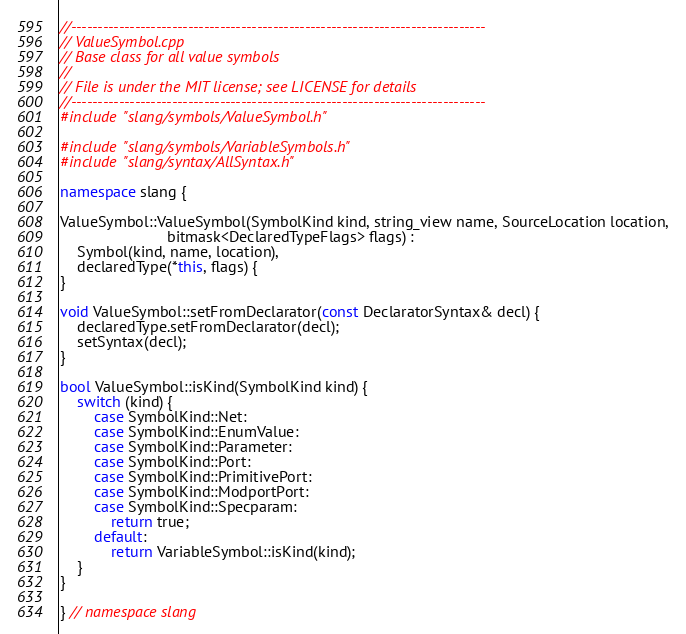<code> <loc_0><loc_0><loc_500><loc_500><_C++_>//------------------------------------------------------------------------------
// ValueSymbol.cpp
// Base class for all value symbols
//
// File is under the MIT license; see LICENSE for details
//------------------------------------------------------------------------------
#include "slang/symbols/ValueSymbol.h"

#include "slang/symbols/VariableSymbols.h"
#include "slang/syntax/AllSyntax.h"

namespace slang {

ValueSymbol::ValueSymbol(SymbolKind kind, string_view name, SourceLocation location,
                         bitmask<DeclaredTypeFlags> flags) :
    Symbol(kind, name, location),
    declaredType(*this, flags) {
}

void ValueSymbol::setFromDeclarator(const DeclaratorSyntax& decl) {
    declaredType.setFromDeclarator(decl);
    setSyntax(decl);
}

bool ValueSymbol::isKind(SymbolKind kind) {
    switch (kind) {
        case SymbolKind::Net:
        case SymbolKind::EnumValue:
        case SymbolKind::Parameter:
        case SymbolKind::Port:
        case SymbolKind::PrimitivePort:
        case SymbolKind::ModportPort:
        case SymbolKind::Specparam:
            return true;
        default:
            return VariableSymbol::isKind(kind);
    }
}

} // namespace slang
</code> 